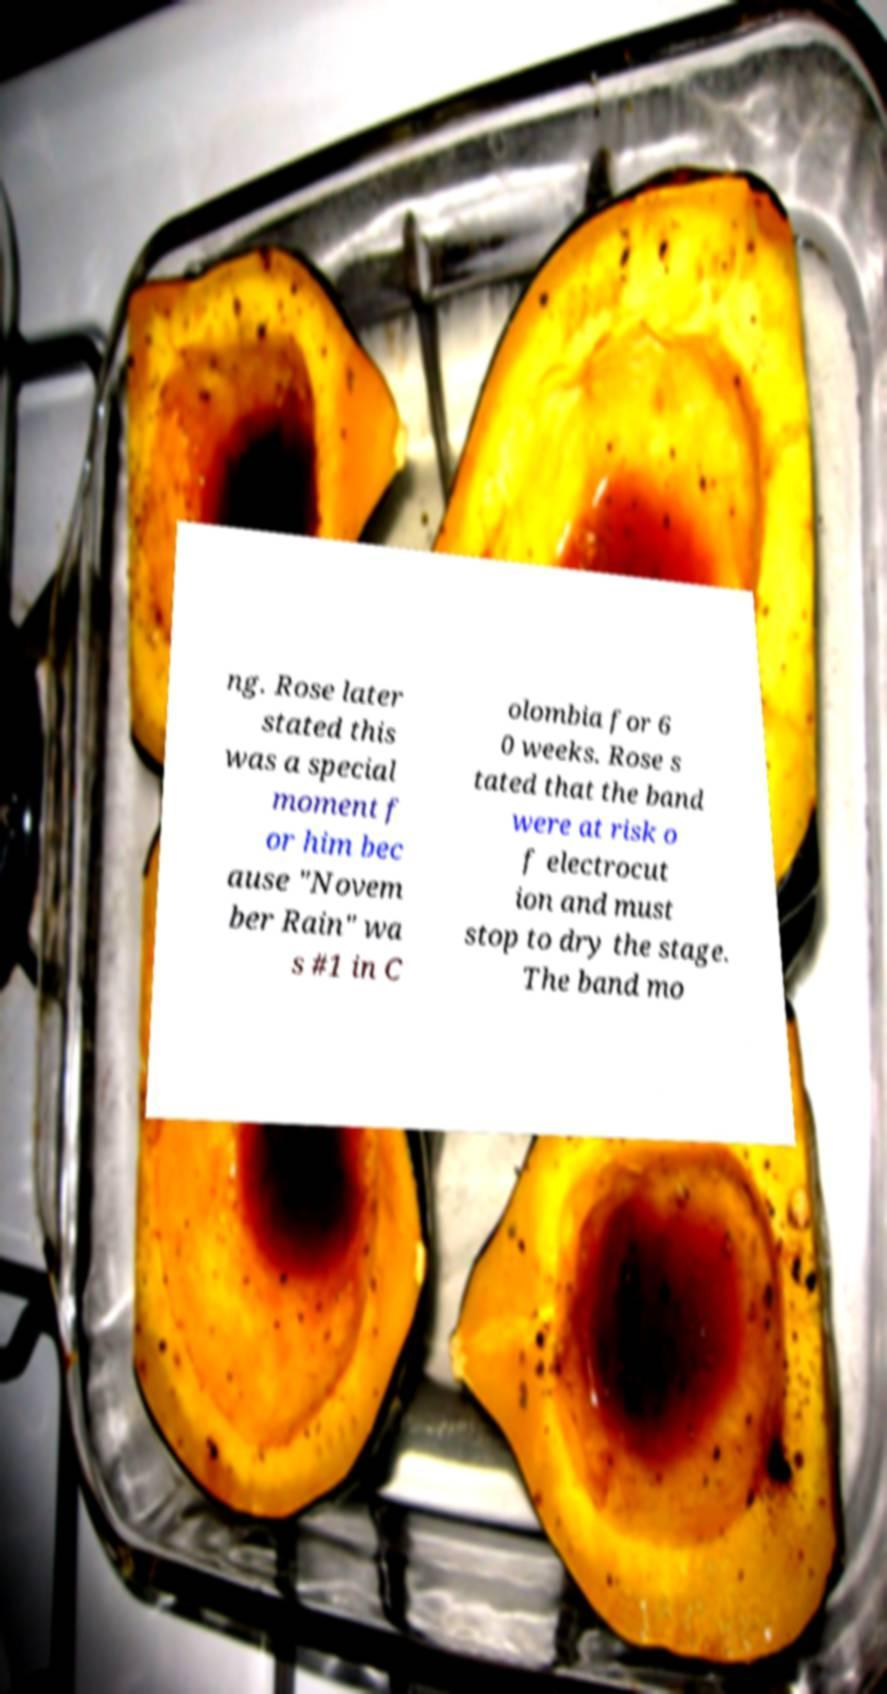Please identify and transcribe the text found in this image. ng. Rose later stated this was a special moment f or him bec ause "Novem ber Rain" wa s #1 in C olombia for 6 0 weeks. Rose s tated that the band were at risk o f electrocut ion and must stop to dry the stage. The band mo 